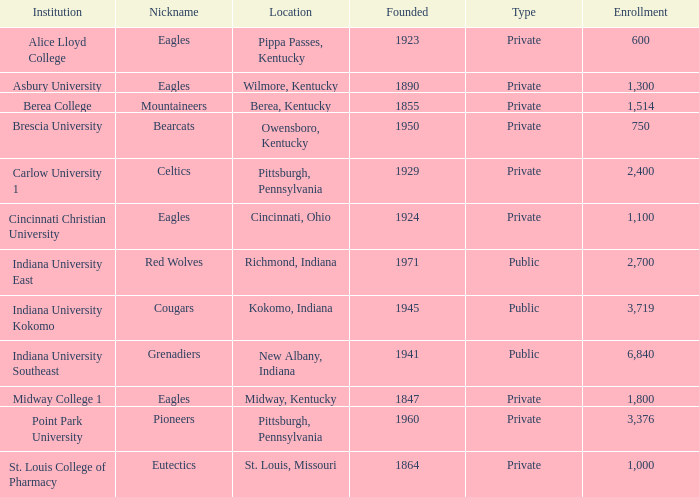Which college's enrollment is less than 1,000? Alice Lloyd College, Brescia University. 